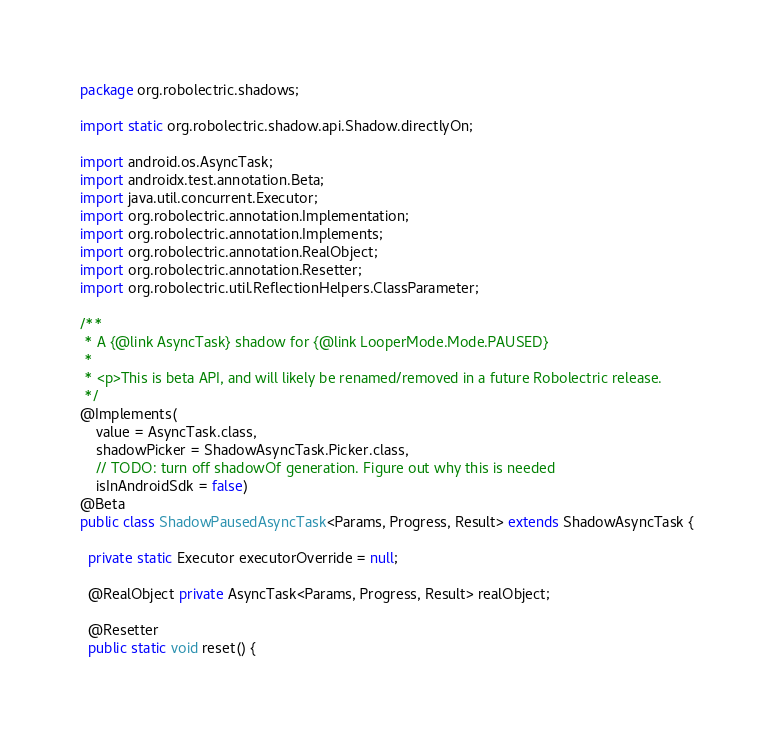<code> <loc_0><loc_0><loc_500><loc_500><_Java_>package org.robolectric.shadows;

import static org.robolectric.shadow.api.Shadow.directlyOn;

import android.os.AsyncTask;
import androidx.test.annotation.Beta;
import java.util.concurrent.Executor;
import org.robolectric.annotation.Implementation;
import org.robolectric.annotation.Implements;
import org.robolectric.annotation.RealObject;
import org.robolectric.annotation.Resetter;
import org.robolectric.util.ReflectionHelpers.ClassParameter;

/**
 * A {@link AsyncTask} shadow for {@link LooperMode.Mode.PAUSED}
 *
 * <p>This is beta API, and will likely be renamed/removed in a future Robolectric release.
 */
@Implements(
    value = AsyncTask.class,
    shadowPicker = ShadowAsyncTask.Picker.class,
    // TODO: turn off shadowOf generation. Figure out why this is needed
    isInAndroidSdk = false)
@Beta
public class ShadowPausedAsyncTask<Params, Progress, Result> extends ShadowAsyncTask {

  private static Executor executorOverride = null;

  @RealObject private AsyncTask<Params, Progress, Result> realObject;

  @Resetter
  public static void reset() {</code> 